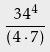Convert formula to latex. <formula><loc_0><loc_0><loc_500><loc_500>\frac { 3 4 ^ { 4 } } { ( 4 \cdot 7 ) }</formula> 